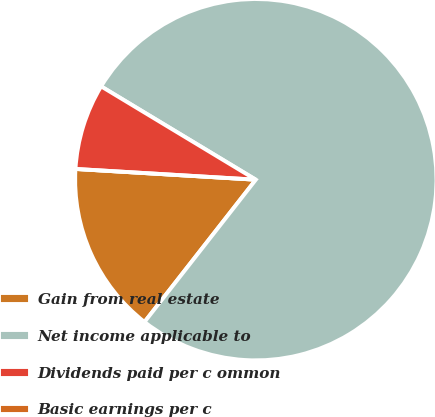<chart> <loc_0><loc_0><loc_500><loc_500><pie_chart><fcel>Gain from real estate<fcel>Net income applicable to<fcel>Dividends paid per c ommon<fcel>Basic earnings per c<nl><fcel>15.38%<fcel>76.92%<fcel>7.69%<fcel>0.0%<nl></chart> 